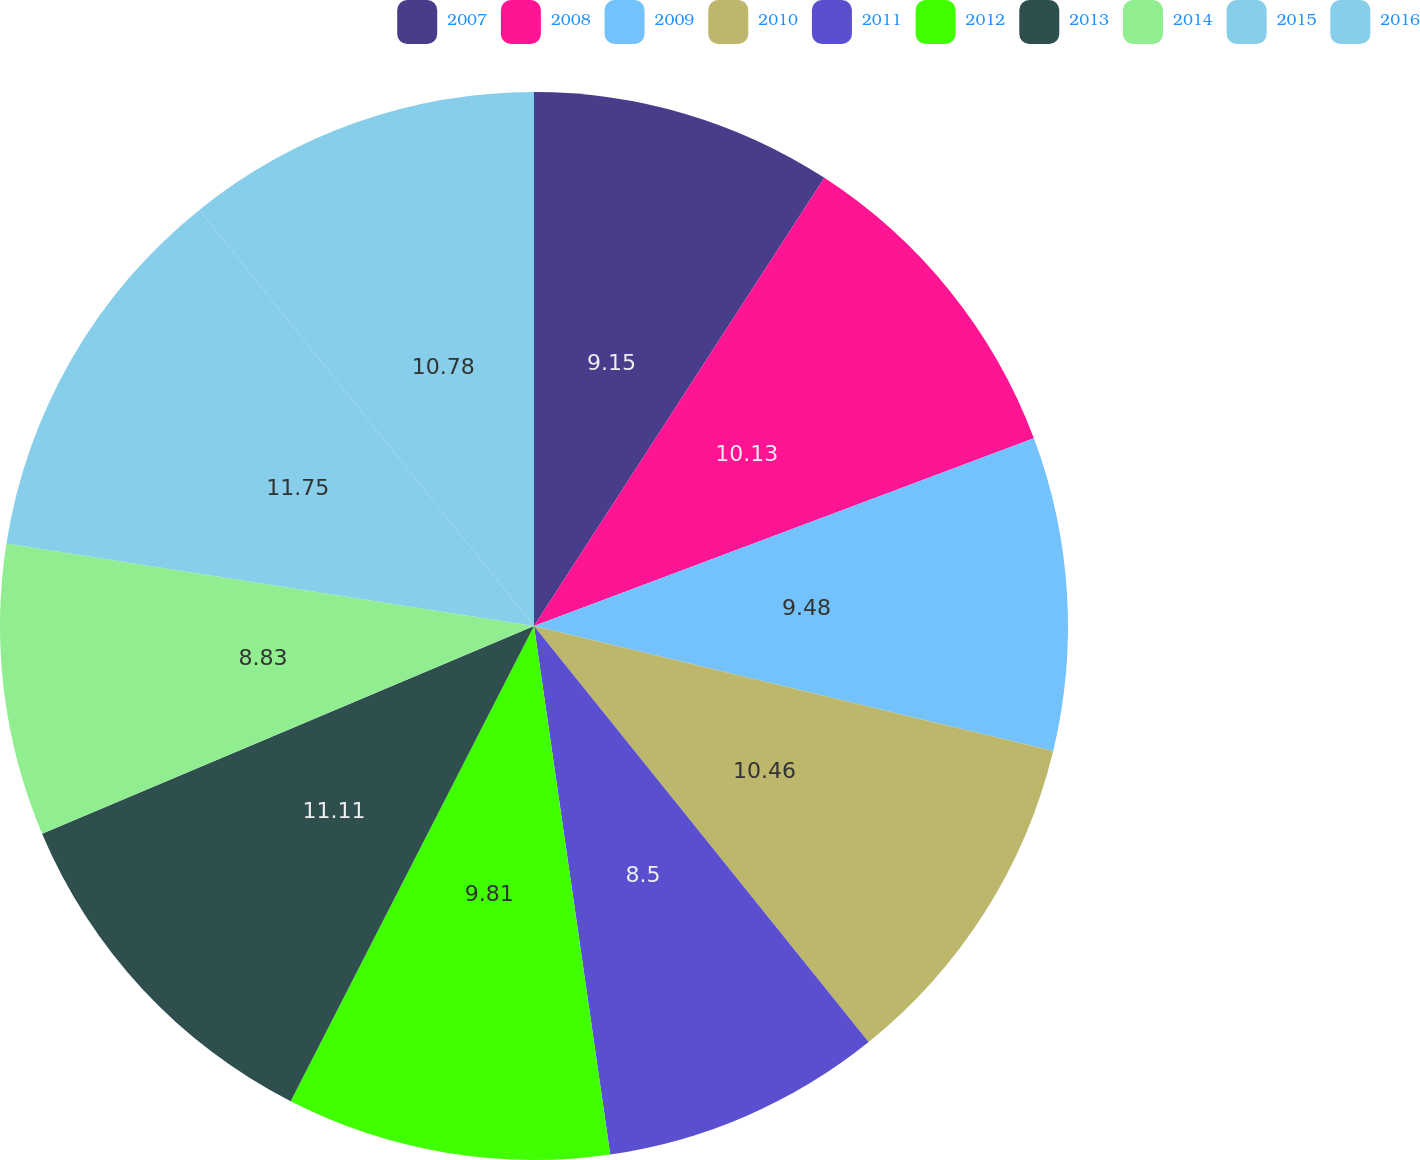<chart> <loc_0><loc_0><loc_500><loc_500><pie_chart><fcel>2007<fcel>2008<fcel>2009<fcel>2010<fcel>2011<fcel>2012<fcel>2013<fcel>2014<fcel>2015<fcel>2016<nl><fcel>9.15%<fcel>10.13%<fcel>9.48%<fcel>10.46%<fcel>8.5%<fcel>9.81%<fcel>11.11%<fcel>8.83%<fcel>11.75%<fcel>10.78%<nl></chart> 